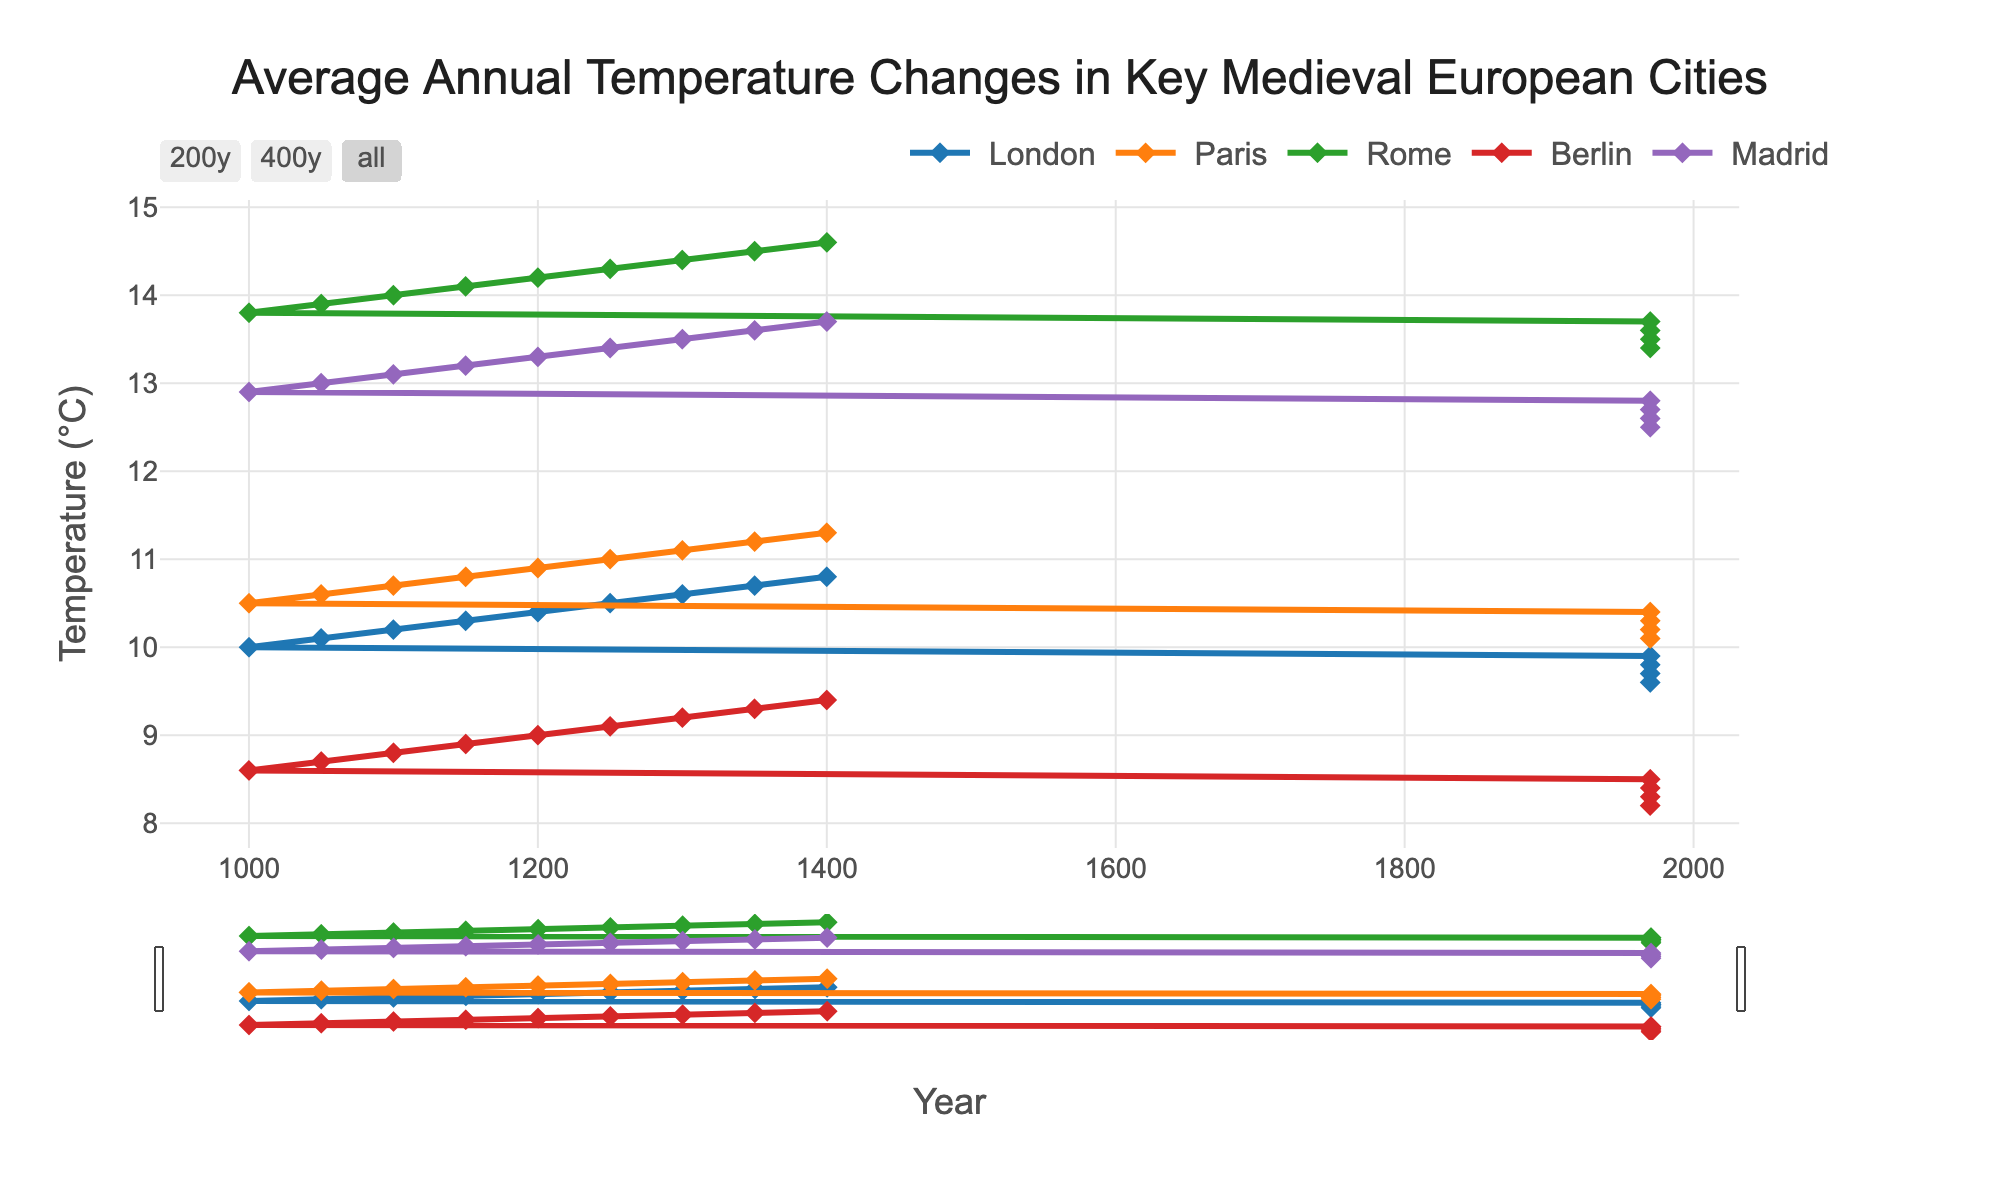What is the title of the figure? The title is located at the top of the figure and describes the content of the plot.
Answer: "Average Annual Temperature Changes in Key Medieval European Cities" How many cities are represented in the figure? Count the distinct traces or lines on the plot, each representing a city.
Answer: Five In which year does Berlin have the lowest temperature shown in the figure? Look at the Berlin trace and find the minimum value, then trace it back to the corresponding year on the x-axis.
Answer: 800 Which city had the highest temperature in 1400? Look at the temperature values for all cities in 1400 and identify the highest one.
Answer: Rome What is the temperature difference between Paris and Madrid in 1200? Locate the temperature values for Paris and Madrid in the year 1200 and subtract the value of Madrid from Paris.
Answer: -2.4 How has London's temperature changed from 800 to 1400? Look at the trend of London's trace from the year 800 to 1400 and summarize the overall direction and changes.
Answer: Increased by 1.2°C (from 9.6°C to 10.8°C) Which city shows the most consistent temperature change over time? Observe each city's trace to determine which one shows the smoothest and most consistent trend without abrupt changes.
Answer: London In what year does Paris' temperature equal Rome's temperature? Identify the year(s) where the temperature values of Paris and Rome intersect or are equal.
Answer: They do not intersect Which two cities had the smallest temperature difference in 1050? Find the temperatures of all cities in 1050, calculate the differences between each pair, and identify the pair with the smallest difference.
Answer: London and Paris (difference of 0.5°C) What is the average temperature in Rome from 800 to 1400? Add up all the temperature values for Rome and divide by the number of data points (13).
Answer: 13.9°C 